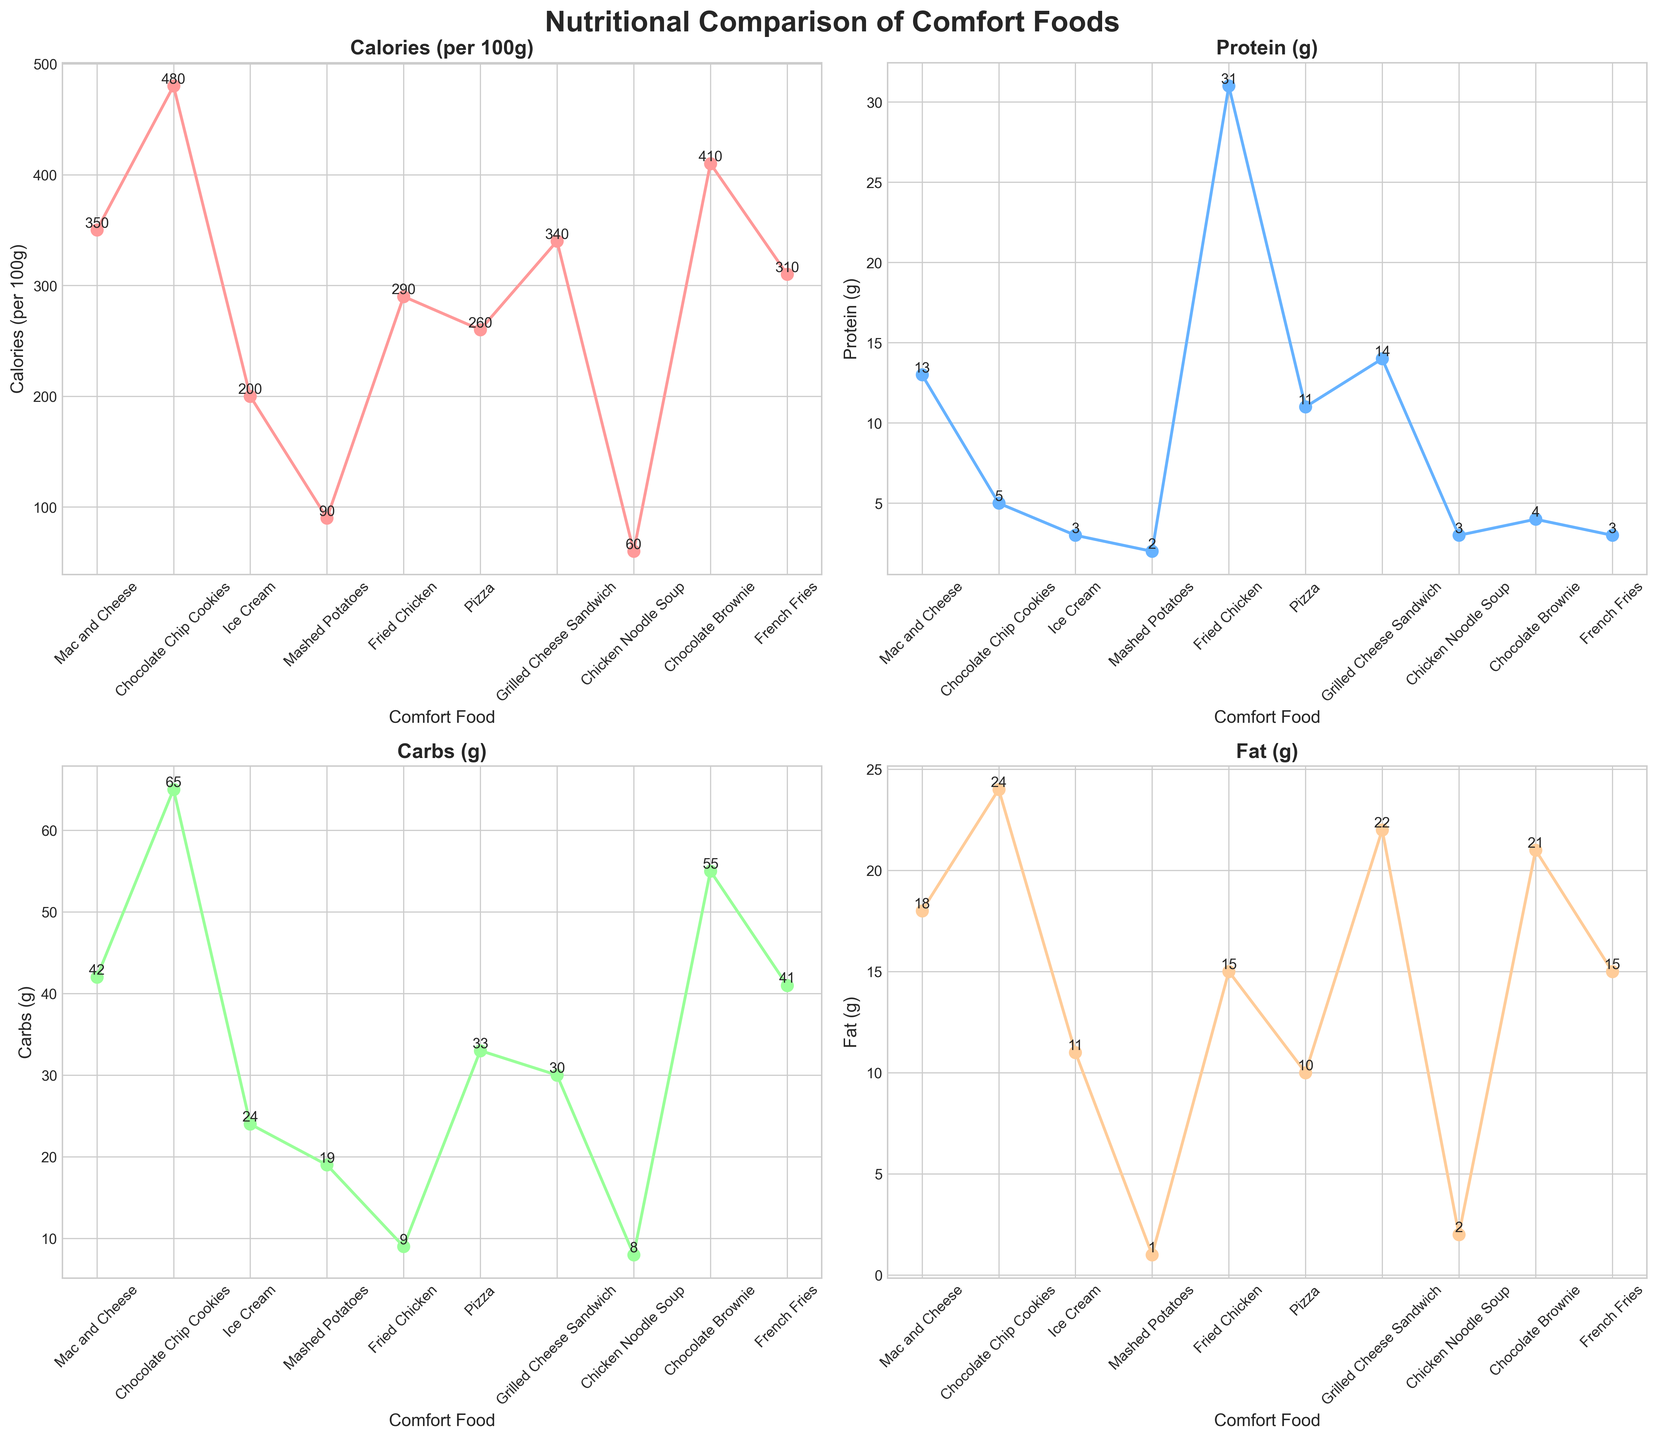Which comfort food has the highest calorie content per 100g? Look at the Calories (per 100g) subplot, identify the point with the highest value, which corresponds to Chocolate Chip Cookies at 480 calories.
Answer: Chocolate Chip Cookies What is the average protein content for Grilled Cheese Sandwich and Fried Chicken? Identify the protein values for each: Grilled Cheese Sandwich has 14g and Fried Chicken has 31g. Sum these values (14 + 31 = 45) and then divide by 2 to find the average, which is 45 / 2 = 22.5g.
Answer: 22.5g How does the carbohydrate content of Ice Cream compare to that of Mashed Potatoes? In the Carbs (g) subplot, observe that Ice Cream has 24g and Mashed Potatoes have 19g. Ice Cream has 5g more carbs than Mashed Potatoes (24 - 19 = 5g).
Answer: Ice Cream has 5g more Which comfort food has the least sodium content? Look at the Sodium (mg) values in the Calories (per 100g) subplot. Chicken Noodle Soup has the lowest sodium content of 60mg.
Answer: Ice Cream Between Mac and Cheese and Fried Chicken, which one has more fat content? Refer to the Fat (g) subplot where Mac and Cheese has 18g of fat and Fried Chicken has 15g of fat. Mac and Cheese has 3g more fat than Fried Chicken (18 - 15 = 3g).
Answer: Mac and Cheese What is the total carbohydrate content of Pizza, Mac and Cheese, and French Fries combined? Identify the carbohydrate values for each: Pizza has 33g, Mac and Cheese has 42g, and French Fries have 41g. Sum these values (33 + 42 + 41 = 116g).
Answer: 116g Which foods have the same protein content, and what is that amount? In the Protein (g) subplot, identify that Mac and Cheese and Grilled Cheese Sandwich both have 14g of protein.
Answer: Mac and Cheese and Grilled Cheese Sandwich, 14g What's the difference in fat content between Chocolate Brownie and Grilled Cheese Sandwich? Refer to the Fat (g) subplot where Chocolate Brownie has 21g of fat and Grilled Cheese Sandwich has 22g of fat. The difference is 1g (22 - 21 = 1g).
Answer: 1g Which comfort food stands out by having the lowest protein content? In the Protein (g) subplot, observe that Mashed Potatoes has the lowest protein content with only 2g.
Answer: Mashed Potatoes 